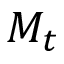Convert formula to latex. <formula><loc_0><loc_0><loc_500><loc_500>M _ { t }</formula> 